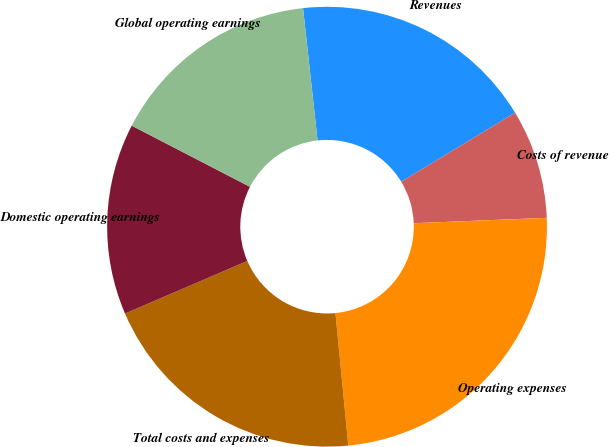Convert chart to OTSL. <chart><loc_0><loc_0><loc_500><loc_500><pie_chart><fcel>Revenues<fcel>Costs of revenue<fcel>Operating expenses<fcel>Total costs and expenses<fcel>Domestic operating earnings<fcel>Global operating earnings<nl><fcel>18.07%<fcel>8.03%<fcel>24.1%<fcel>20.08%<fcel>14.06%<fcel>15.66%<nl></chart> 